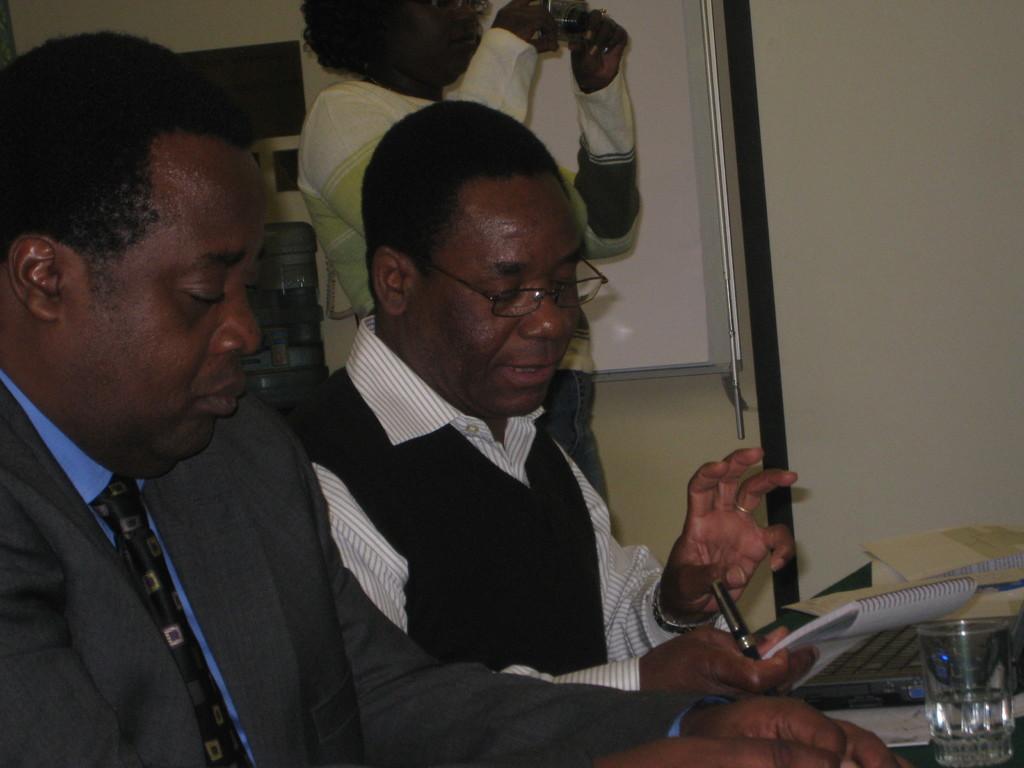Please provide a concise description of this image. There are two persons sitting. One person is holding a pen and book. There is a table. On that there is a glass, keyboard and books. In the back a person is standing and holding a camera. There is a wall. On that there is a board. Also there is a water can in the back. 